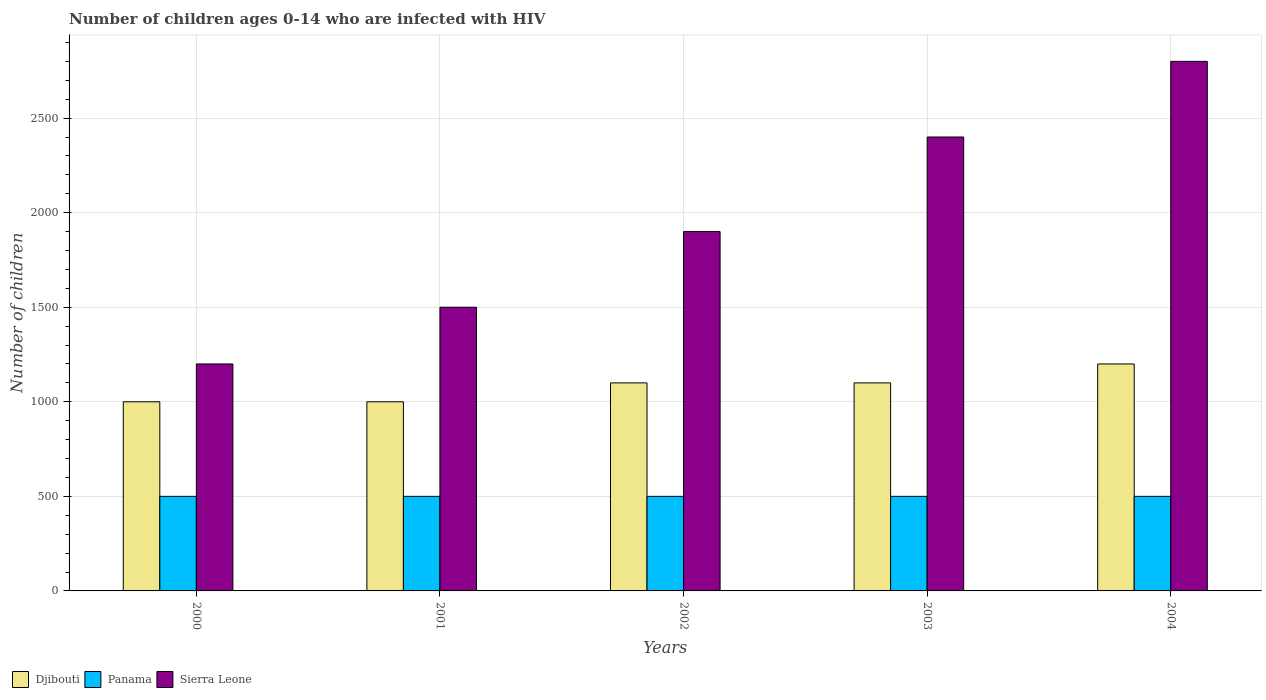How many groups of bars are there?
Your answer should be very brief. 5. Are the number of bars on each tick of the X-axis equal?
Your answer should be very brief. Yes. How many bars are there on the 5th tick from the right?
Your answer should be very brief. 3. What is the label of the 1st group of bars from the left?
Provide a succinct answer. 2000. What is the number of HIV infected children in Djibouti in 2003?
Keep it short and to the point. 1100. Across all years, what is the maximum number of HIV infected children in Panama?
Offer a terse response. 500. Across all years, what is the minimum number of HIV infected children in Panama?
Ensure brevity in your answer.  500. In which year was the number of HIV infected children in Djibouti maximum?
Provide a short and direct response. 2004. In which year was the number of HIV infected children in Djibouti minimum?
Offer a very short reply. 2000. What is the total number of HIV infected children in Sierra Leone in the graph?
Offer a terse response. 9800. What is the difference between the number of HIV infected children in Djibouti in 2002 and that in 2003?
Give a very brief answer. 0. What is the difference between the number of HIV infected children in Sierra Leone in 2000 and the number of HIV infected children in Panama in 2001?
Keep it short and to the point. 700. What is the average number of HIV infected children in Panama per year?
Your response must be concise. 500. In the year 2002, what is the difference between the number of HIV infected children in Panama and number of HIV infected children in Djibouti?
Your answer should be compact. -600. In how many years, is the number of HIV infected children in Panama greater than 2200?
Ensure brevity in your answer.  0. What is the ratio of the number of HIV infected children in Djibouti in 2000 to that in 2004?
Offer a very short reply. 0.83. Is the difference between the number of HIV infected children in Panama in 2000 and 2002 greater than the difference between the number of HIV infected children in Djibouti in 2000 and 2002?
Make the answer very short. Yes. What is the difference between the highest and the second highest number of HIV infected children in Panama?
Make the answer very short. 0. What is the difference between the highest and the lowest number of HIV infected children in Djibouti?
Offer a very short reply. 200. In how many years, is the number of HIV infected children in Sierra Leone greater than the average number of HIV infected children in Sierra Leone taken over all years?
Give a very brief answer. 2. Is the sum of the number of HIV infected children in Sierra Leone in 2003 and 2004 greater than the maximum number of HIV infected children in Djibouti across all years?
Your response must be concise. Yes. What does the 3rd bar from the left in 2001 represents?
Your answer should be compact. Sierra Leone. What does the 3rd bar from the right in 2003 represents?
Your answer should be very brief. Djibouti. Is it the case that in every year, the sum of the number of HIV infected children in Djibouti and number of HIV infected children in Panama is greater than the number of HIV infected children in Sierra Leone?
Your answer should be very brief. No. Are all the bars in the graph horizontal?
Provide a succinct answer. No. How many years are there in the graph?
Offer a terse response. 5. Does the graph contain grids?
Your response must be concise. Yes. How are the legend labels stacked?
Your response must be concise. Horizontal. What is the title of the graph?
Make the answer very short. Number of children ages 0-14 who are infected with HIV. Does "Cyprus" appear as one of the legend labels in the graph?
Your answer should be very brief. No. What is the label or title of the Y-axis?
Make the answer very short. Number of children. What is the Number of children of Sierra Leone in 2000?
Offer a very short reply. 1200. What is the Number of children of Djibouti in 2001?
Keep it short and to the point. 1000. What is the Number of children in Panama in 2001?
Your answer should be compact. 500. What is the Number of children of Sierra Leone in 2001?
Your answer should be compact. 1500. What is the Number of children of Djibouti in 2002?
Your response must be concise. 1100. What is the Number of children in Panama in 2002?
Your answer should be compact. 500. What is the Number of children of Sierra Leone in 2002?
Ensure brevity in your answer.  1900. What is the Number of children of Djibouti in 2003?
Offer a very short reply. 1100. What is the Number of children of Panama in 2003?
Your response must be concise. 500. What is the Number of children of Sierra Leone in 2003?
Offer a terse response. 2400. What is the Number of children of Djibouti in 2004?
Offer a terse response. 1200. What is the Number of children in Sierra Leone in 2004?
Keep it short and to the point. 2800. Across all years, what is the maximum Number of children of Djibouti?
Your answer should be compact. 1200. Across all years, what is the maximum Number of children of Panama?
Give a very brief answer. 500. Across all years, what is the maximum Number of children of Sierra Leone?
Offer a terse response. 2800. Across all years, what is the minimum Number of children of Panama?
Your response must be concise. 500. Across all years, what is the minimum Number of children of Sierra Leone?
Offer a very short reply. 1200. What is the total Number of children of Djibouti in the graph?
Give a very brief answer. 5400. What is the total Number of children of Panama in the graph?
Provide a succinct answer. 2500. What is the total Number of children of Sierra Leone in the graph?
Provide a short and direct response. 9800. What is the difference between the Number of children of Djibouti in 2000 and that in 2001?
Your answer should be compact. 0. What is the difference between the Number of children of Sierra Leone in 2000 and that in 2001?
Your answer should be very brief. -300. What is the difference between the Number of children in Djibouti in 2000 and that in 2002?
Give a very brief answer. -100. What is the difference between the Number of children of Panama in 2000 and that in 2002?
Keep it short and to the point. 0. What is the difference between the Number of children in Sierra Leone in 2000 and that in 2002?
Ensure brevity in your answer.  -700. What is the difference between the Number of children of Djibouti in 2000 and that in 2003?
Provide a short and direct response. -100. What is the difference between the Number of children of Panama in 2000 and that in 2003?
Your answer should be very brief. 0. What is the difference between the Number of children of Sierra Leone in 2000 and that in 2003?
Your answer should be compact. -1200. What is the difference between the Number of children in Djibouti in 2000 and that in 2004?
Provide a short and direct response. -200. What is the difference between the Number of children of Sierra Leone in 2000 and that in 2004?
Provide a succinct answer. -1600. What is the difference between the Number of children in Djibouti in 2001 and that in 2002?
Give a very brief answer. -100. What is the difference between the Number of children in Sierra Leone in 2001 and that in 2002?
Provide a short and direct response. -400. What is the difference between the Number of children in Djibouti in 2001 and that in 2003?
Your response must be concise. -100. What is the difference between the Number of children of Panama in 2001 and that in 2003?
Offer a terse response. 0. What is the difference between the Number of children in Sierra Leone in 2001 and that in 2003?
Provide a succinct answer. -900. What is the difference between the Number of children of Djibouti in 2001 and that in 2004?
Your answer should be very brief. -200. What is the difference between the Number of children of Sierra Leone in 2001 and that in 2004?
Keep it short and to the point. -1300. What is the difference between the Number of children in Panama in 2002 and that in 2003?
Make the answer very short. 0. What is the difference between the Number of children in Sierra Leone in 2002 and that in 2003?
Keep it short and to the point. -500. What is the difference between the Number of children in Djibouti in 2002 and that in 2004?
Your answer should be compact. -100. What is the difference between the Number of children in Sierra Leone in 2002 and that in 2004?
Your response must be concise. -900. What is the difference between the Number of children of Djibouti in 2003 and that in 2004?
Your response must be concise. -100. What is the difference between the Number of children of Panama in 2003 and that in 2004?
Ensure brevity in your answer.  0. What is the difference between the Number of children in Sierra Leone in 2003 and that in 2004?
Your answer should be very brief. -400. What is the difference between the Number of children in Djibouti in 2000 and the Number of children in Sierra Leone in 2001?
Keep it short and to the point. -500. What is the difference between the Number of children of Panama in 2000 and the Number of children of Sierra Leone in 2001?
Your response must be concise. -1000. What is the difference between the Number of children in Djibouti in 2000 and the Number of children in Sierra Leone in 2002?
Provide a succinct answer. -900. What is the difference between the Number of children of Panama in 2000 and the Number of children of Sierra Leone in 2002?
Your response must be concise. -1400. What is the difference between the Number of children of Djibouti in 2000 and the Number of children of Sierra Leone in 2003?
Offer a very short reply. -1400. What is the difference between the Number of children in Panama in 2000 and the Number of children in Sierra Leone in 2003?
Provide a succinct answer. -1900. What is the difference between the Number of children in Djibouti in 2000 and the Number of children in Sierra Leone in 2004?
Provide a succinct answer. -1800. What is the difference between the Number of children in Panama in 2000 and the Number of children in Sierra Leone in 2004?
Give a very brief answer. -2300. What is the difference between the Number of children in Djibouti in 2001 and the Number of children in Panama in 2002?
Offer a very short reply. 500. What is the difference between the Number of children in Djibouti in 2001 and the Number of children in Sierra Leone in 2002?
Provide a succinct answer. -900. What is the difference between the Number of children of Panama in 2001 and the Number of children of Sierra Leone in 2002?
Give a very brief answer. -1400. What is the difference between the Number of children of Djibouti in 2001 and the Number of children of Sierra Leone in 2003?
Make the answer very short. -1400. What is the difference between the Number of children in Panama in 2001 and the Number of children in Sierra Leone in 2003?
Offer a terse response. -1900. What is the difference between the Number of children in Djibouti in 2001 and the Number of children in Panama in 2004?
Give a very brief answer. 500. What is the difference between the Number of children of Djibouti in 2001 and the Number of children of Sierra Leone in 2004?
Your answer should be very brief. -1800. What is the difference between the Number of children in Panama in 2001 and the Number of children in Sierra Leone in 2004?
Your answer should be very brief. -2300. What is the difference between the Number of children of Djibouti in 2002 and the Number of children of Panama in 2003?
Ensure brevity in your answer.  600. What is the difference between the Number of children in Djibouti in 2002 and the Number of children in Sierra Leone in 2003?
Offer a terse response. -1300. What is the difference between the Number of children of Panama in 2002 and the Number of children of Sierra Leone in 2003?
Your answer should be very brief. -1900. What is the difference between the Number of children of Djibouti in 2002 and the Number of children of Panama in 2004?
Provide a succinct answer. 600. What is the difference between the Number of children of Djibouti in 2002 and the Number of children of Sierra Leone in 2004?
Ensure brevity in your answer.  -1700. What is the difference between the Number of children of Panama in 2002 and the Number of children of Sierra Leone in 2004?
Give a very brief answer. -2300. What is the difference between the Number of children in Djibouti in 2003 and the Number of children in Panama in 2004?
Offer a very short reply. 600. What is the difference between the Number of children of Djibouti in 2003 and the Number of children of Sierra Leone in 2004?
Provide a short and direct response. -1700. What is the difference between the Number of children of Panama in 2003 and the Number of children of Sierra Leone in 2004?
Provide a short and direct response. -2300. What is the average Number of children in Djibouti per year?
Offer a very short reply. 1080. What is the average Number of children in Panama per year?
Provide a short and direct response. 500. What is the average Number of children in Sierra Leone per year?
Ensure brevity in your answer.  1960. In the year 2000, what is the difference between the Number of children of Djibouti and Number of children of Panama?
Offer a very short reply. 500. In the year 2000, what is the difference between the Number of children of Djibouti and Number of children of Sierra Leone?
Keep it short and to the point. -200. In the year 2000, what is the difference between the Number of children in Panama and Number of children in Sierra Leone?
Your response must be concise. -700. In the year 2001, what is the difference between the Number of children of Djibouti and Number of children of Sierra Leone?
Your answer should be very brief. -500. In the year 2001, what is the difference between the Number of children in Panama and Number of children in Sierra Leone?
Make the answer very short. -1000. In the year 2002, what is the difference between the Number of children of Djibouti and Number of children of Panama?
Your answer should be compact. 600. In the year 2002, what is the difference between the Number of children of Djibouti and Number of children of Sierra Leone?
Provide a short and direct response. -800. In the year 2002, what is the difference between the Number of children in Panama and Number of children in Sierra Leone?
Provide a short and direct response. -1400. In the year 2003, what is the difference between the Number of children of Djibouti and Number of children of Panama?
Keep it short and to the point. 600. In the year 2003, what is the difference between the Number of children in Djibouti and Number of children in Sierra Leone?
Offer a terse response. -1300. In the year 2003, what is the difference between the Number of children of Panama and Number of children of Sierra Leone?
Your response must be concise. -1900. In the year 2004, what is the difference between the Number of children of Djibouti and Number of children of Panama?
Keep it short and to the point. 700. In the year 2004, what is the difference between the Number of children in Djibouti and Number of children in Sierra Leone?
Make the answer very short. -1600. In the year 2004, what is the difference between the Number of children of Panama and Number of children of Sierra Leone?
Your answer should be compact. -2300. What is the ratio of the Number of children of Sierra Leone in 2000 to that in 2001?
Your answer should be very brief. 0.8. What is the ratio of the Number of children in Djibouti in 2000 to that in 2002?
Your response must be concise. 0.91. What is the ratio of the Number of children in Panama in 2000 to that in 2002?
Keep it short and to the point. 1. What is the ratio of the Number of children of Sierra Leone in 2000 to that in 2002?
Offer a very short reply. 0.63. What is the ratio of the Number of children of Panama in 2000 to that in 2003?
Offer a terse response. 1. What is the ratio of the Number of children of Djibouti in 2000 to that in 2004?
Provide a succinct answer. 0.83. What is the ratio of the Number of children in Panama in 2000 to that in 2004?
Ensure brevity in your answer.  1. What is the ratio of the Number of children of Sierra Leone in 2000 to that in 2004?
Make the answer very short. 0.43. What is the ratio of the Number of children of Panama in 2001 to that in 2002?
Give a very brief answer. 1. What is the ratio of the Number of children in Sierra Leone in 2001 to that in 2002?
Keep it short and to the point. 0.79. What is the ratio of the Number of children of Djibouti in 2001 to that in 2003?
Your answer should be very brief. 0.91. What is the ratio of the Number of children of Panama in 2001 to that in 2003?
Keep it short and to the point. 1. What is the ratio of the Number of children in Sierra Leone in 2001 to that in 2003?
Offer a very short reply. 0.62. What is the ratio of the Number of children of Sierra Leone in 2001 to that in 2004?
Offer a very short reply. 0.54. What is the ratio of the Number of children in Panama in 2002 to that in 2003?
Provide a short and direct response. 1. What is the ratio of the Number of children in Sierra Leone in 2002 to that in 2003?
Ensure brevity in your answer.  0.79. What is the ratio of the Number of children in Panama in 2002 to that in 2004?
Your answer should be compact. 1. What is the ratio of the Number of children in Sierra Leone in 2002 to that in 2004?
Your answer should be very brief. 0.68. What is the ratio of the Number of children in Sierra Leone in 2003 to that in 2004?
Your response must be concise. 0.86. What is the difference between the highest and the second highest Number of children in Panama?
Provide a short and direct response. 0. What is the difference between the highest and the second highest Number of children of Sierra Leone?
Provide a succinct answer. 400. What is the difference between the highest and the lowest Number of children in Djibouti?
Your answer should be compact. 200. What is the difference between the highest and the lowest Number of children of Panama?
Provide a short and direct response. 0. What is the difference between the highest and the lowest Number of children of Sierra Leone?
Provide a succinct answer. 1600. 